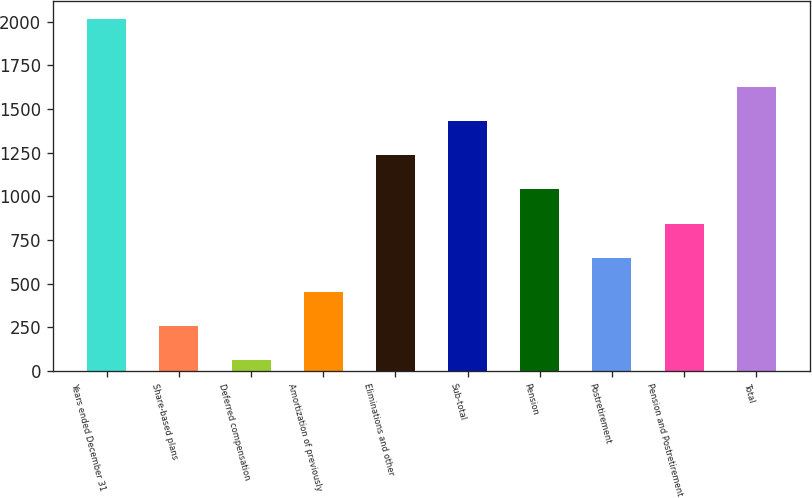Convert chart. <chart><loc_0><loc_0><loc_500><loc_500><bar_chart><fcel>Years ended December 31<fcel>Share-based plans<fcel>Deferred compensation<fcel>Amortization of previously<fcel>Eliminations and other<fcel>Sub-total<fcel>Pension<fcel>Postretirement<fcel>Pension and Postretirement<fcel>Total<nl><fcel>2015<fcel>258.2<fcel>63<fcel>453.4<fcel>1234.2<fcel>1429.4<fcel>1039<fcel>648.6<fcel>843.8<fcel>1624.6<nl></chart> 